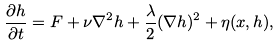Convert formula to latex. <formula><loc_0><loc_0><loc_500><loc_500>\frac { \partial h } { \partial t } = F + \nu \nabla ^ { 2 } h + \frac { \lambda } 2 ( \nabla h ) ^ { 2 } + \eta ( { x } , h ) ,</formula> 